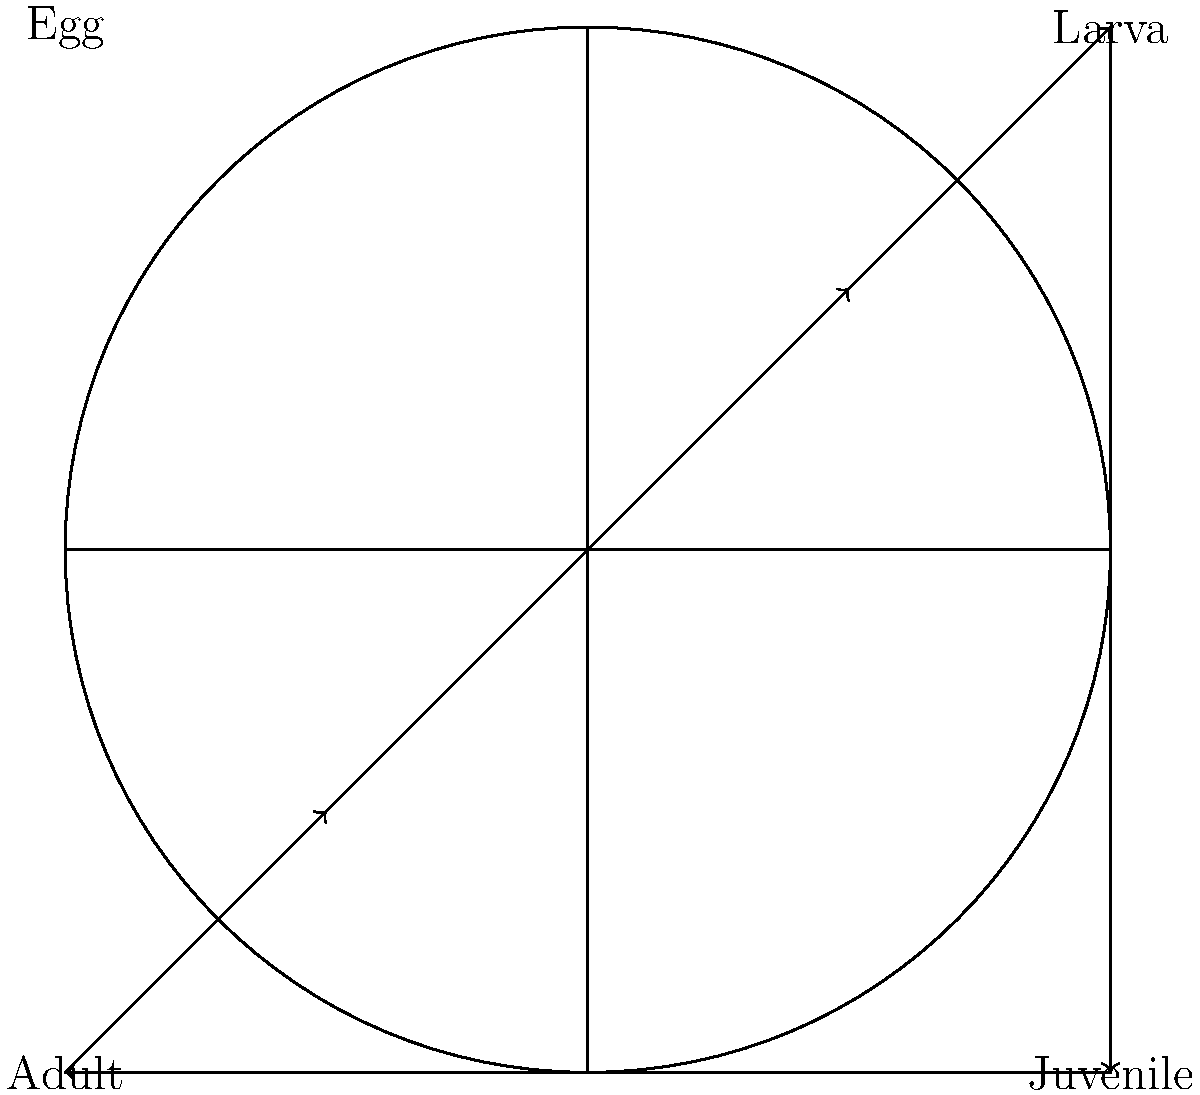I diagrammet ovan visas livscykeln för en sällsynt bläckfiskart. Vilken fas kommer direkt efter larvstadiet i denna arts utveckling? För att besvara denna fråga, låt oss följa livscykeln steg för steg:

1. Livscykeln börjar med ägget (Egg) i det övre vänstra hörnet.
2. Från ägget utvecklas larven (Larva) i det övre högra hörnet.
3. Efter larvstadiet ser vi en pil som pekar nedåt till det nedre högra hörnet.
4. I det nedre högra hörnet finner vi juvenilen (Juvenile).
5. Från juvenilen går utvecklingen vidare till vuxenstadiet (Adult) i det nedre vänstra hörnet.
6. Cykeln avslutas när den vuxna individen lägger ägg och processen börjar om.

Baserat på diagrammet och denna stegvisa analys kan vi se att fasen som kommer direkt efter larvstadiet är juvenilstadiet.
Answer: Juvenile 